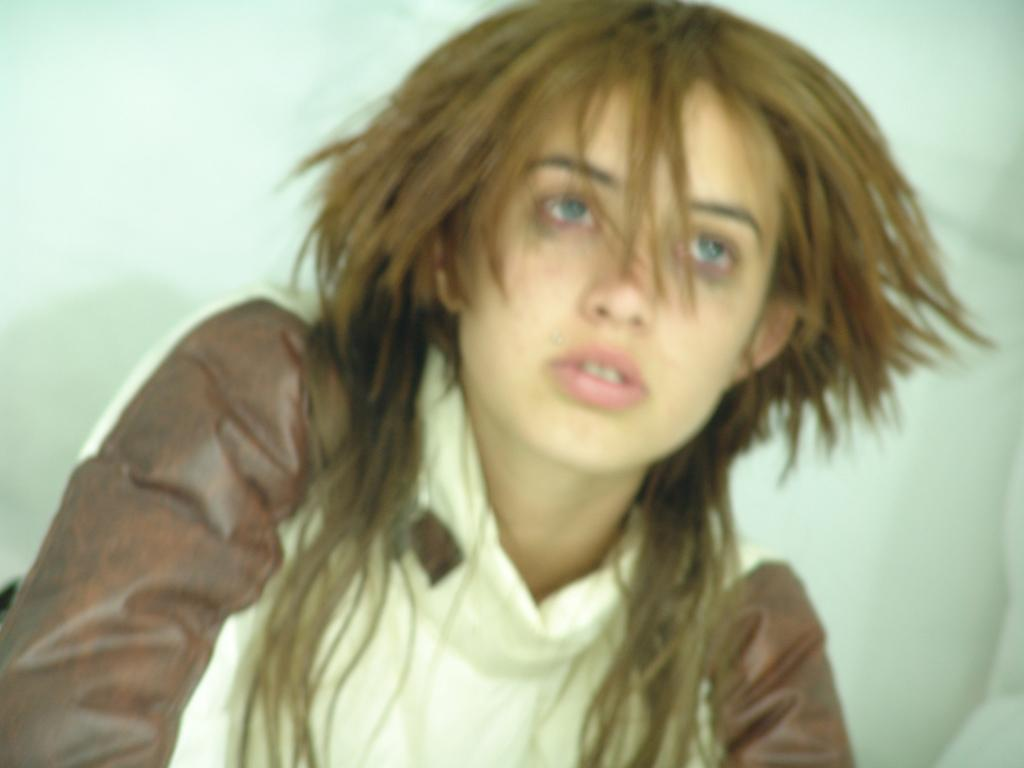Who is the main subject in the image? There is a woman in the image. What is the woman wearing? The woman is wearing a T-shirt. Can you describe the colors of the T-shirt? The T-shirt is white and brown in color. What can be seen in the background of the image? The background of the image appears to be white. What type of poison is the woman using in the image? There is no poison present in the image; the woman is simply wearing a white and brown T-shirt in front of a white background. 